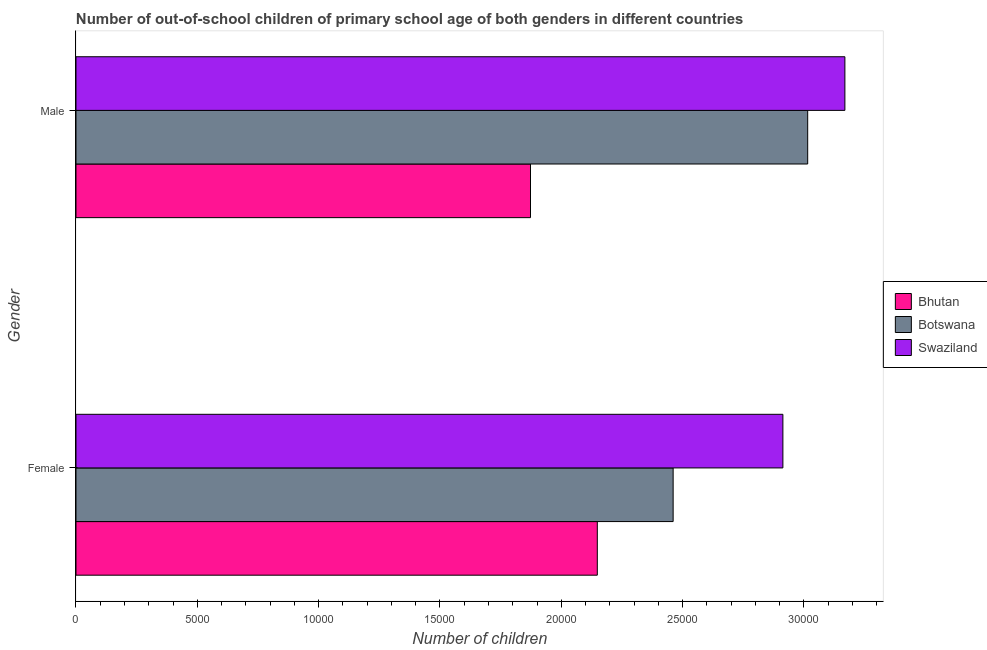How many different coloured bars are there?
Your response must be concise. 3. Are the number of bars per tick equal to the number of legend labels?
Provide a succinct answer. Yes. Are the number of bars on each tick of the Y-axis equal?
Your answer should be compact. Yes. What is the label of the 1st group of bars from the top?
Your response must be concise. Male. What is the number of female out-of-school students in Swaziland?
Provide a short and direct response. 2.91e+04. Across all countries, what is the maximum number of female out-of-school students?
Make the answer very short. 2.91e+04. Across all countries, what is the minimum number of female out-of-school students?
Provide a succinct answer. 2.15e+04. In which country was the number of male out-of-school students maximum?
Give a very brief answer. Swaziland. In which country was the number of male out-of-school students minimum?
Provide a succinct answer. Bhutan. What is the total number of male out-of-school students in the graph?
Provide a short and direct response. 8.06e+04. What is the difference between the number of female out-of-school students in Botswana and that in Bhutan?
Your answer should be very brief. 3125. What is the difference between the number of male out-of-school students in Botswana and the number of female out-of-school students in Bhutan?
Your response must be concise. 8670. What is the average number of male out-of-school students per country?
Ensure brevity in your answer.  2.69e+04. What is the difference between the number of male out-of-school students and number of female out-of-school students in Swaziland?
Ensure brevity in your answer.  2555. In how many countries, is the number of female out-of-school students greater than 27000 ?
Provide a short and direct response. 1. What is the ratio of the number of male out-of-school students in Botswana to that in Bhutan?
Offer a very short reply. 1.61. Is the number of female out-of-school students in Bhutan less than that in Swaziland?
Your answer should be compact. Yes. What does the 1st bar from the top in Female represents?
Provide a short and direct response. Swaziland. What does the 1st bar from the bottom in Female represents?
Ensure brevity in your answer.  Bhutan. How many bars are there?
Offer a terse response. 6. What is the difference between two consecutive major ticks on the X-axis?
Keep it short and to the point. 5000. Are the values on the major ticks of X-axis written in scientific E-notation?
Offer a very short reply. No. Does the graph contain grids?
Keep it short and to the point. No. What is the title of the graph?
Give a very brief answer. Number of out-of-school children of primary school age of both genders in different countries. Does "Oman" appear as one of the legend labels in the graph?
Your answer should be compact. No. What is the label or title of the X-axis?
Ensure brevity in your answer.  Number of children. What is the label or title of the Y-axis?
Your answer should be compact. Gender. What is the Number of children in Bhutan in Female?
Your answer should be compact. 2.15e+04. What is the Number of children of Botswana in Female?
Provide a succinct answer. 2.46e+04. What is the Number of children of Swaziland in Female?
Your answer should be compact. 2.91e+04. What is the Number of children of Bhutan in Male?
Your response must be concise. 1.87e+04. What is the Number of children of Botswana in Male?
Keep it short and to the point. 3.02e+04. What is the Number of children in Swaziland in Male?
Ensure brevity in your answer.  3.17e+04. Across all Gender, what is the maximum Number of children in Bhutan?
Ensure brevity in your answer.  2.15e+04. Across all Gender, what is the maximum Number of children in Botswana?
Give a very brief answer. 3.02e+04. Across all Gender, what is the maximum Number of children in Swaziland?
Keep it short and to the point. 3.17e+04. Across all Gender, what is the minimum Number of children of Bhutan?
Make the answer very short. 1.87e+04. Across all Gender, what is the minimum Number of children of Botswana?
Your answer should be compact. 2.46e+04. Across all Gender, what is the minimum Number of children in Swaziland?
Offer a very short reply. 2.91e+04. What is the total Number of children in Bhutan in the graph?
Offer a very short reply. 4.02e+04. What is the total Number of children of Botswana in the graph?
Provide a succinct answer. 5.48e+04. What is the total Number of children of Swaziland in the graph?
Make the answer very short. 6.08e+04. What is the difference between the Number of children in Bhutan in Female and that in Male?
Ensure brevity in your answer.  2753. What is the difference between the Number of children in Botswana in Female and that in Male?
Provide a short and direct response. -5545. What is the difference between the Number of children of Swaziland in Female and that in Male?
Make the answer very short. -2555. What is the difference between the Number of children in Bhutan in Female and the Number of children in Botswana in Male?
Give a very brief answer. -8670. What is the difference between the Number of children of Bhutan in Female and the Number of children of Swaziland in Male?
Your answer should be very brief. -1.02e+04. What is the difference between the Number of children in Botswana in Female and the Number of children in Swaziland in Male?
Your answer should be compact. -7078. What is the average Number of children of Bhutan per Gender?
Keep it short and to the point. 2.01e+04. What is the average Number of children of Botswana per Gender?
Give a very brief answer. 2.74e+04. What is the average Number of children of Swaziland per Gender?
Offer a terse response. 3.04e+04. What is the difference between the Number of children in Bhutan and Number of children in Botswana in Female?
Keep it short and to the point. -3125. What is the difference between the Number of children in Bhutan and Number of children in Swaziland in Female?
Provide a short and direct response. -7648. What is the difference between the Number of children of Botswana and Number of children of Swaziland in Female?
Make the answer very short. -4523. What is the difference between the Number of children of Bhutan and Number of children of Botswana in Male?
Offer a very short reply. -1.14e+04. What is the difference between the Number of children of Bhutan and Number of children of Swaziland in Male?
Your answer should be compact. -1.30e+04. What is the difference between the Number of children in Botswana and Number of children in Swaziland in Male?
Your answer should be very brief. -1533. What is the ratio of the Number of children of Bhutan in Female to that in Male?
Give a very brief answer. 1.15. What is the ratio of the Number of children in Botswana in Female to that in Male?
Your answer should be compact. 0.82. What is the ratio of the Number of children in Swaziland in Female to that in Male?
Keep it short and to the point. 0.92. What is the difference between the highest and the second highest Number of children of Bhutan?
Offer a terse response. 2753. What is the difference between the highest and the second highest Number of children in Botswana?
Keep it short and to the point. 5545. What is the difference between the highest and the second highest Number of children in Swaziland?
Make the answer very short. 2555. What is the difference between the highest and the lowest Number of children of Bhutan?
Make the answer very short. 2753. What is the difference between the highest and the lowest Number of children in Botswana?
Offer a terse response. 5545. What is the difference between the highest and the lowest Number of children of Swaziland?
Ensure brevity in your answer.  2555. 